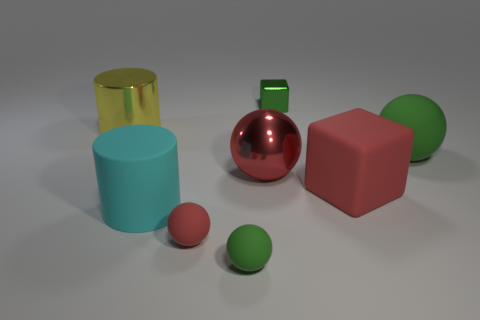How many red balls must be subtracted to get 1 red balls? 1 Subtract all small green rubber balls. How many balls are left? 3 Add 1 yellow shiny objects. How many objects exist? 9 Subtract all cylinders. How many objects are left? 6 Subtract all yellow cylinders. How many cylinders are left? 1 Add 4 green rubber spheres. How many green rubber spheres are left? 6 Add 1 large green matte objects. How many large green matte objects exist? 2 Subtract 0 blue blocks. How many objects are left? 8 Subtract 1 cylinders. How many cylinders are left? 1 Subtract all gray cylinders. Subtract all cyan spheres. How many cylinders are left? 2 